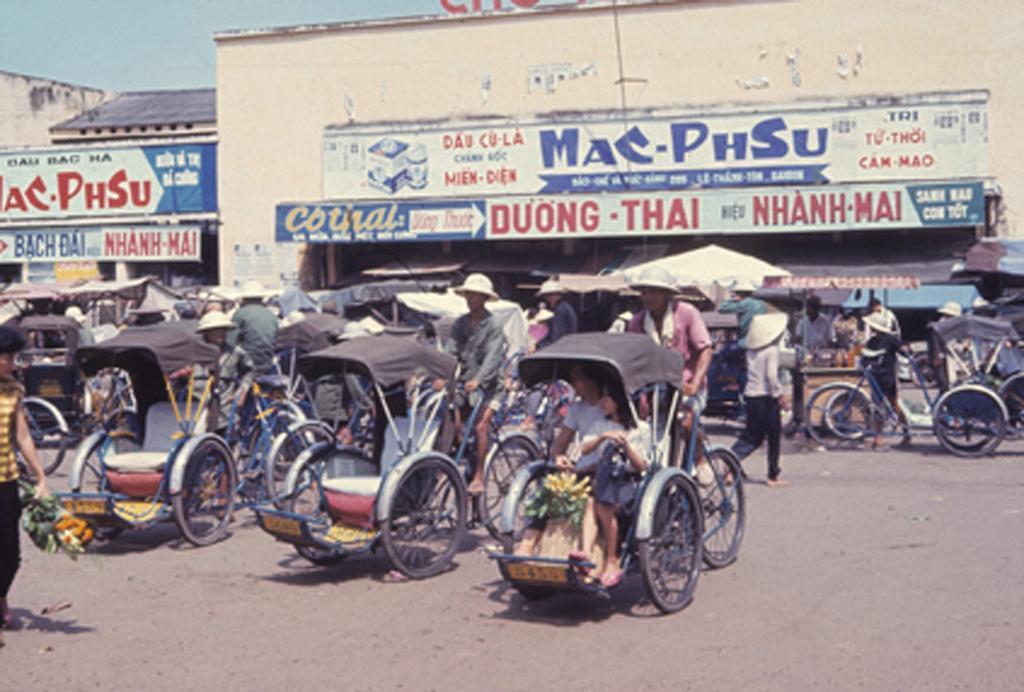Please provide a concise description of this image. In this picture we can see some vehicles are on the road, few people are walking, behind we can see some buildings. 